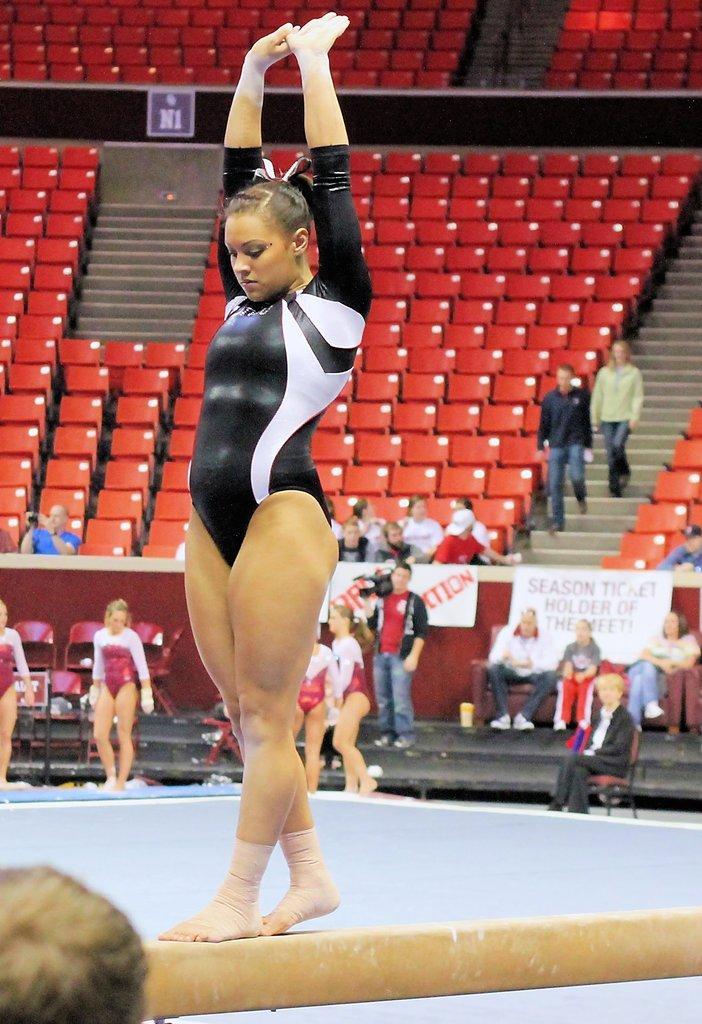How would you summarize this image in a sentence or two? There is a woman wearing black dress is standing on an object and there are few other persons in the background. 